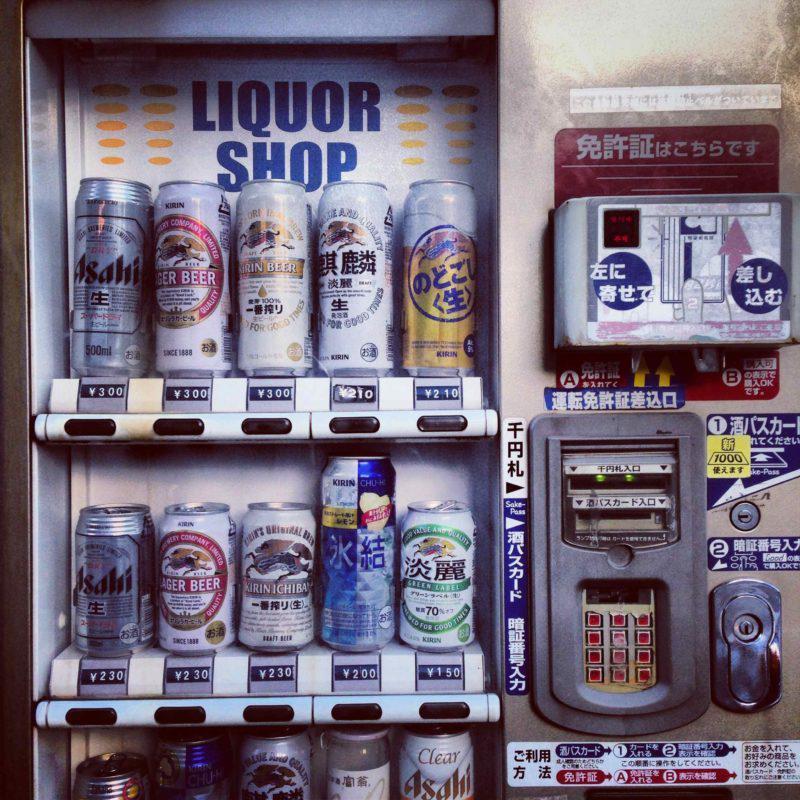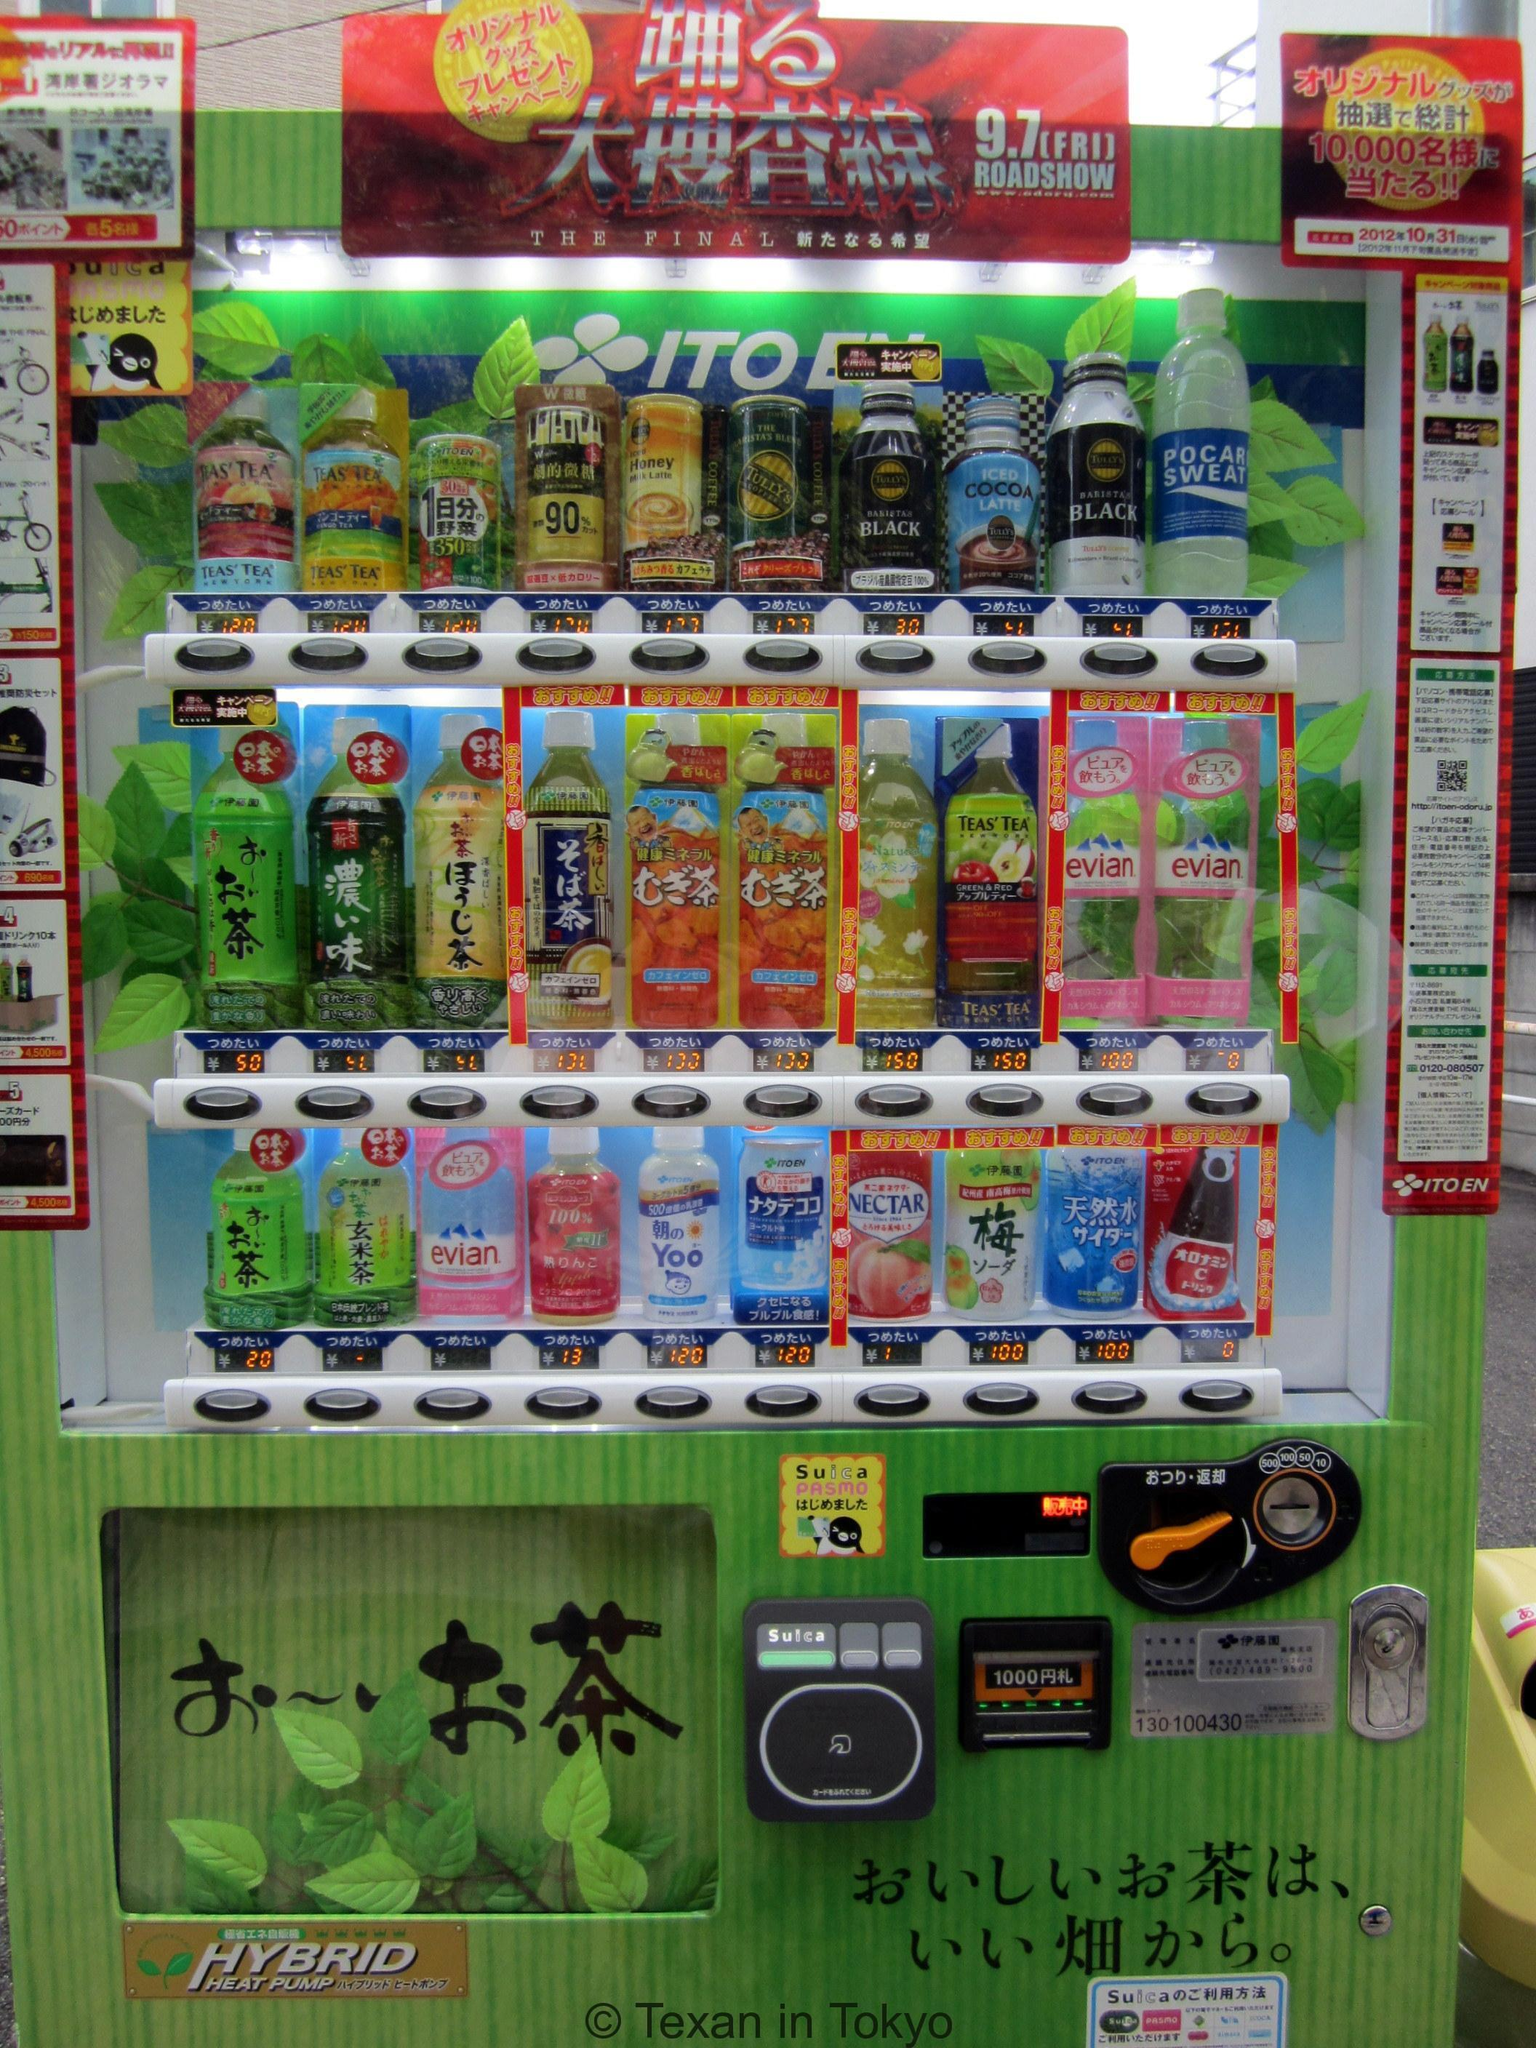The first image is the image on the left, the second image is the image on the right. For the images displayed, is the sentence "The right image shows a row of at least four vending machines." factually correct? Answer yes or no. No. 